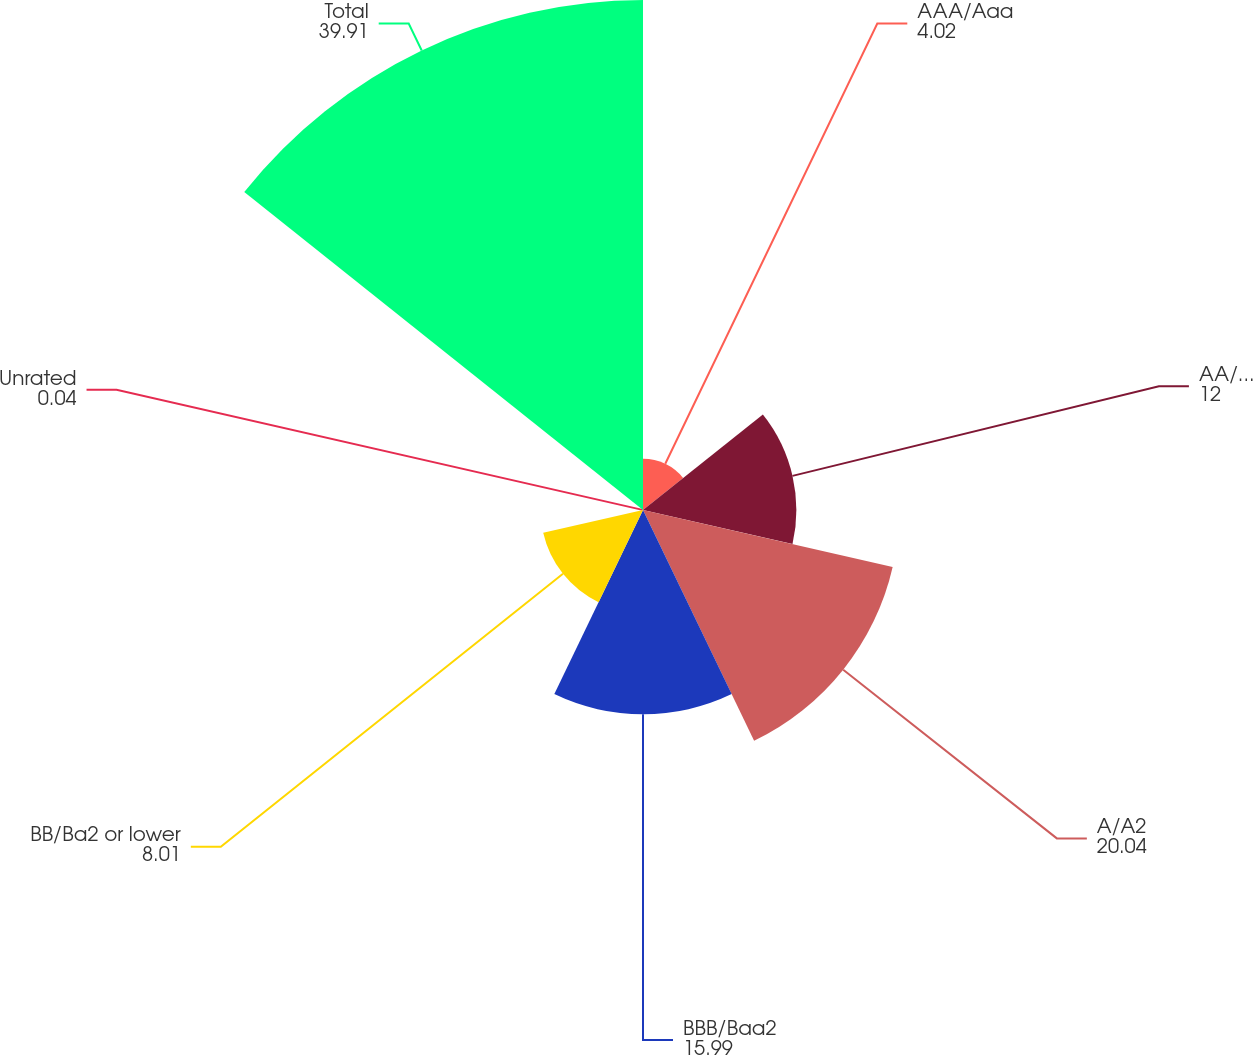Convert chart to OTSL. <chart><loc_0><loc_0><loc_500><loc_500><pie_chart><fcel>AAA/Aaa<fcel>AA/Aa2<fcel>A/A2<fcel>BBB/Baa2<fcel>BB/Ba2 or lower<fcel>Unrated<fcel>Total<nl><fcel>4.02%<fcel>12.0%<fcel>20.04%<fcel>15.99%<fcel>8.01%<fcel>0.04%<fcel>39.91%<nl></chart> 